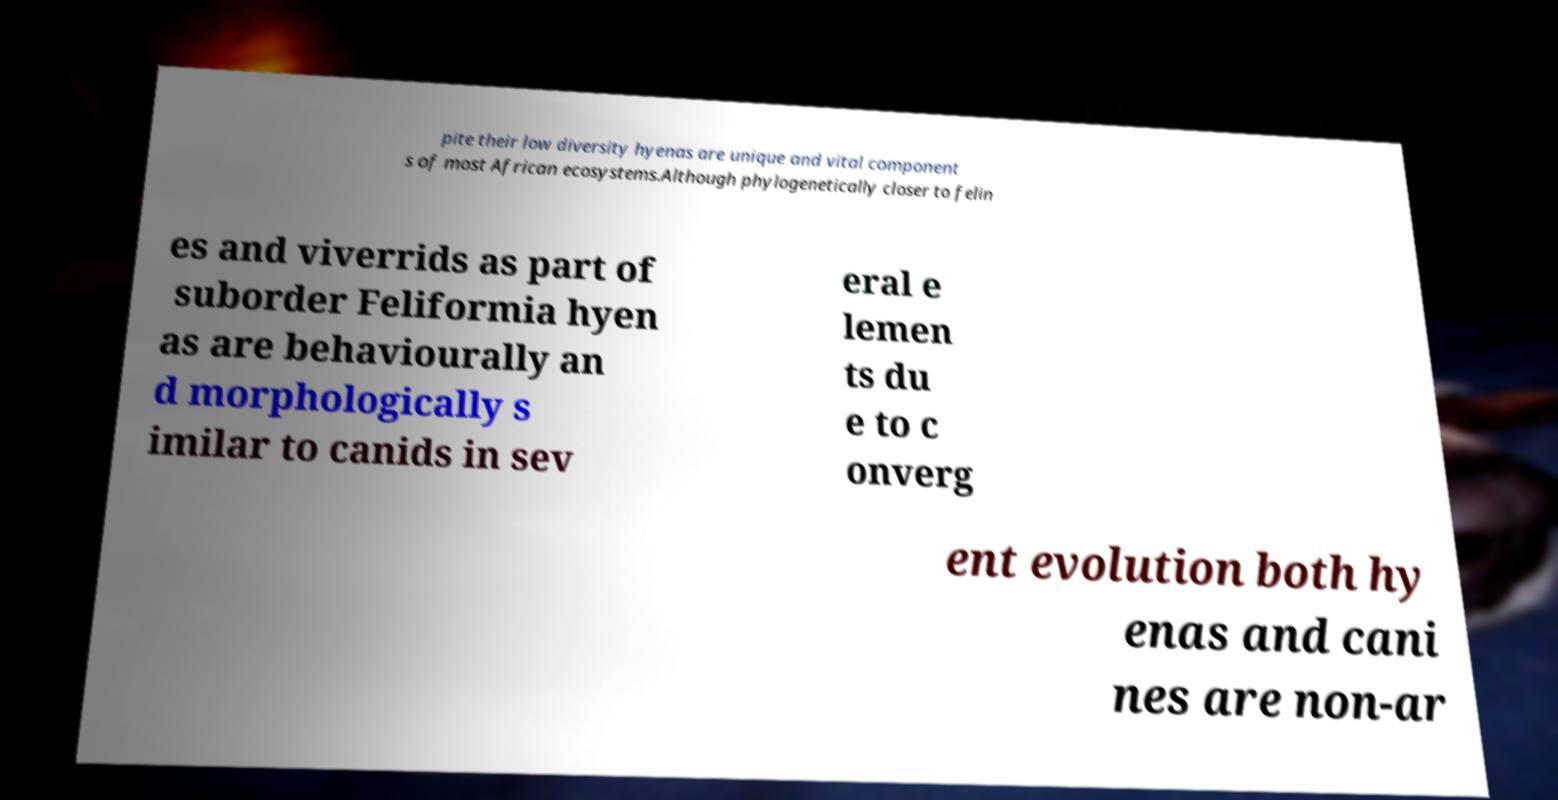There's text embedded in this image that I need extracted. Can you transcribe it verbatim? pite their low diversity hyenas are unique and vital component s of most African ecosystems.Although phylogenetically closer to felin es and viverrids as part of suborder Feliformia hyen as are behaviourally an d morphologically s imilar to canids in sev eral e lemen ts du e to c onverg ent evolution both hy enas and cani nes are non-ar 